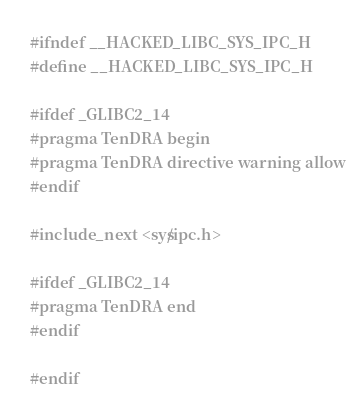Convert code to text. <code><loc_0><loc_0><loc_500><loc_500><_C_>#ifndef __HACKED_LIBC_SYS_IPC_H
#define __HACKED_LIBC_SYS_IPC_H

#ifdef _GLIBC2_14
#pragma TenDRA begin
#pragma TenDRA directive warning allow
#endif

#include_next <sys/ipc.h>

#ifdef _GLIBC2_14
#pragma TenDRA end
#endif

#endif

</code> 